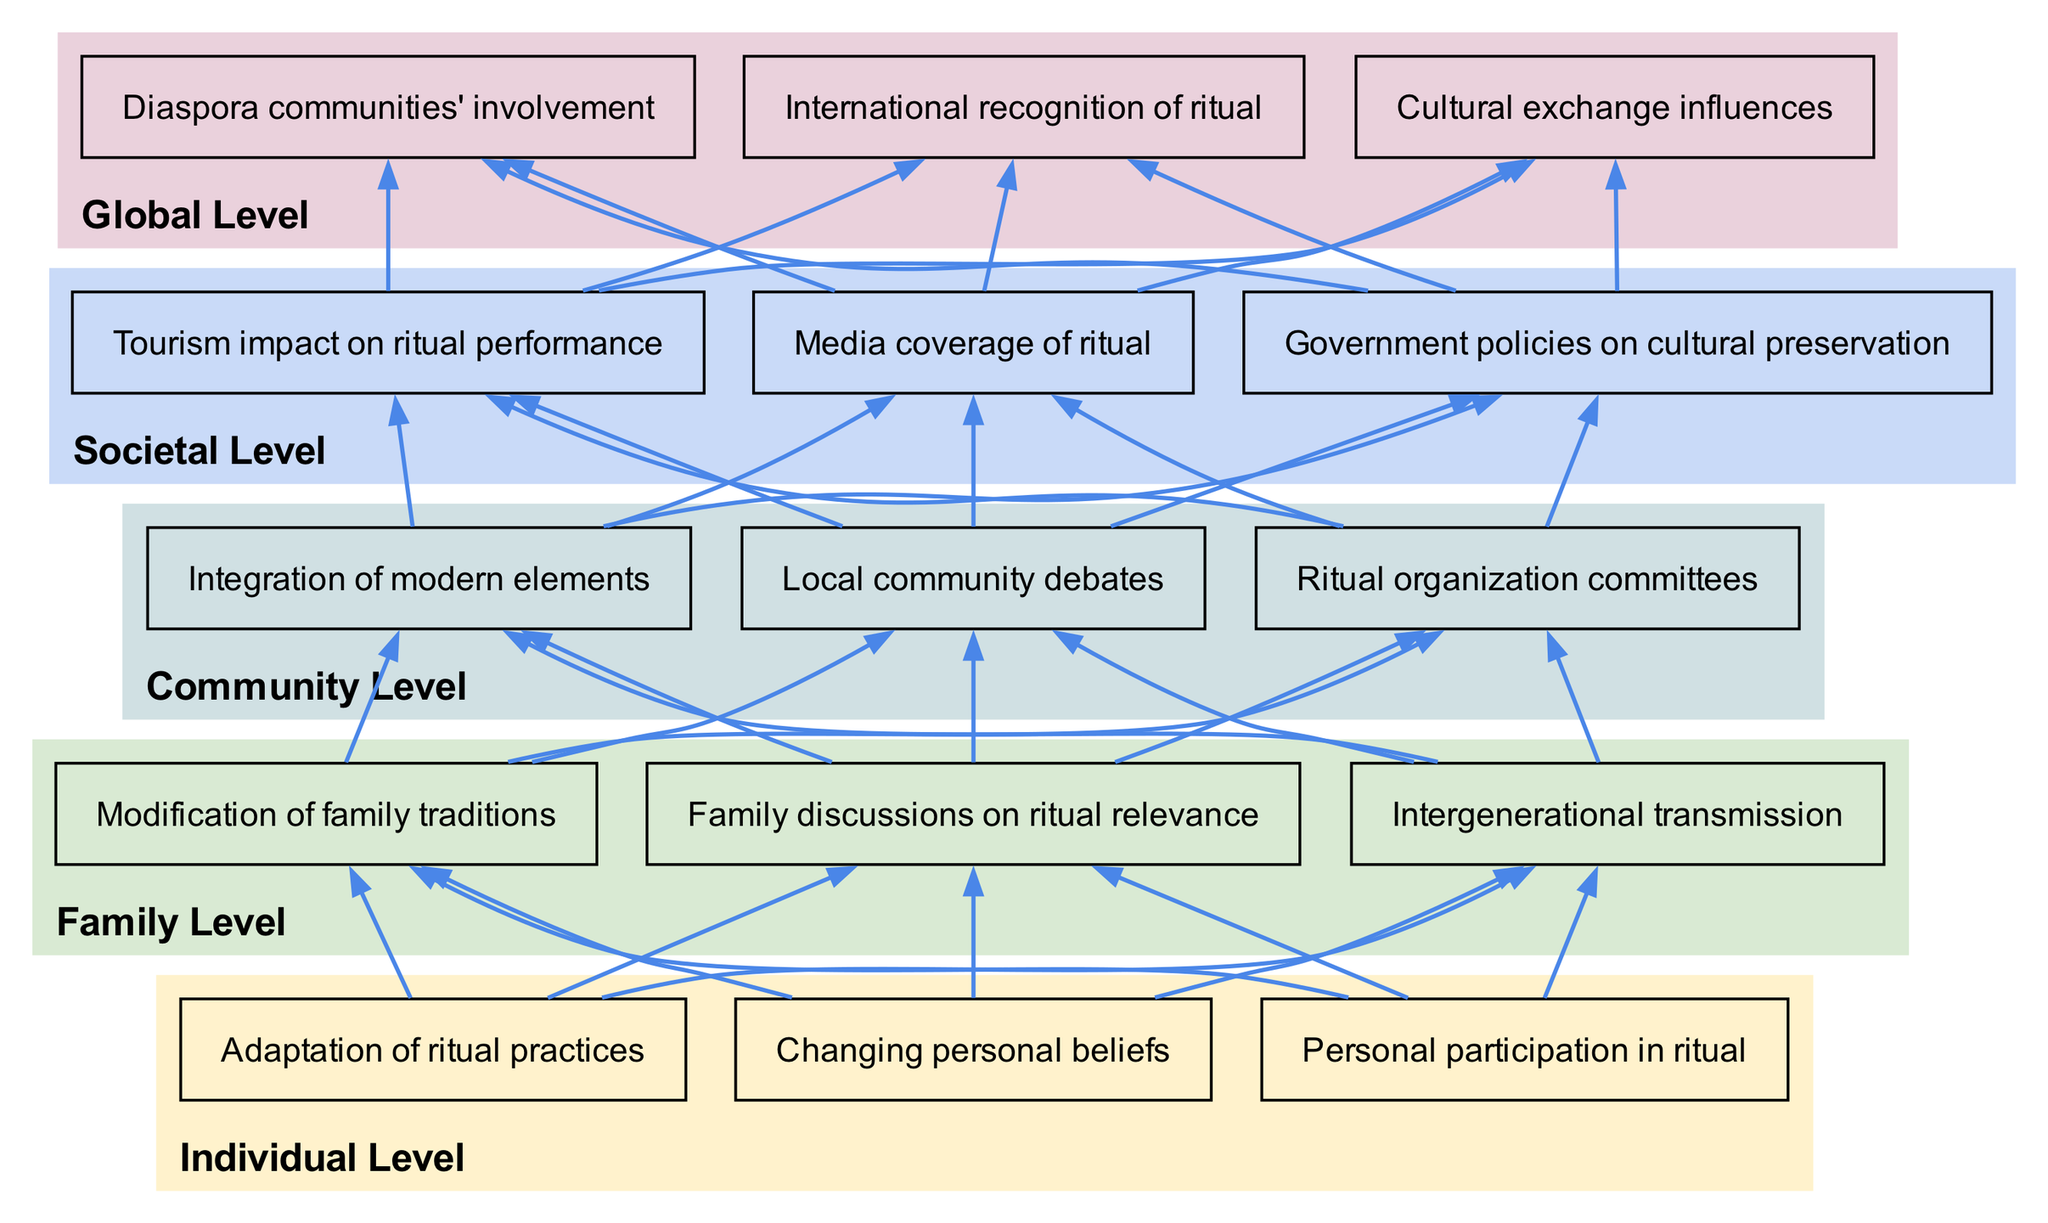What are the three levels of the flow chart? The diagram presents five distinct levels: individualLevel, familyLevel, communityLevel, societalLevel, and globalLevel.
Answer: individualLevel, familyLevel, communityLevel, societalLevel, globalLevel How many nodes are in the community level? Referring to the communityLevel cluster, there are three nodes listed: "Local community debates", "Ritual organization committees", and "Integration of modern elements".
Answer: 3 What is the connection between "Changing personal beliefs" and "Family discussions on ritual relevance"? Tracing the diagram, "Changing personal beliefs" is linked to "Family discussions on ritual relevance" through the flow of influence from the individual level to the family level, indicating that personal beliefs can shape family discussions about rituals.
Answer: Influence Which node is directly connected to "Tourism impact on ritual performance"? Following the path, the node "Media coverage of ritual" is directly connected to "Tourism impact on ritual performance" as a societal impact of the ritual.
Answer: Media coverage of ritual What is the significance of "International recognition of ritual" at the global level? As indicated in the diagram, "International recognition of ritual" implies that the ritual has reached a level of importance beyond the local context, affecting cultural perspectives globally and acknowledging its value in a wider cultural exchange.
Answer: Cultural perspective How many edges connect nodes from individual level to family level? Analyzing the edges, there are three distinct connections from the individual level nodes to the family level nodes, representing the flow of influence from individual experiences to family discussions and traditions.
Answer: 3 Which node indicates adaptation and integration of modern elements in the community level? The node "Integration of modern elements" reflects changes in ritual practices that incorporate contemporary aspects, showing the community's adaptation.
Answer: Integration of modern elements What role does "Government policies on cultural preservation" play in the societal level? "Government policies on cultural preservation" serves as a significant factor that influences rituals by promoting their continuity and relevance in the face of modernization, linking societal interests with traditional practices.
Answer: Promoting continuity 